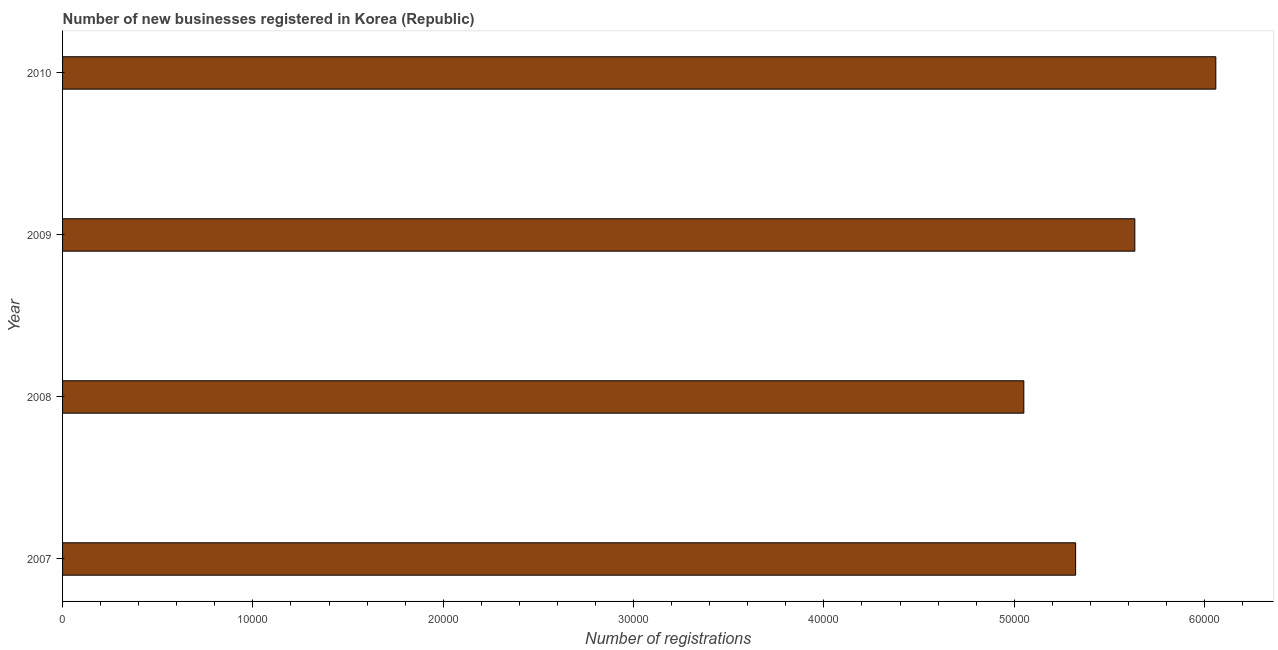Does the graph contain grids?
Provide a succinct answer. No. What is the title of the graph?
Your answer should be very brief. Number of new businesses registered in Korea (Republic). What is the label or title of the X-axis?
Your response must be concise. Number of registrations. What is the number of new business registrations in 2008?
Keep it short and to the point. 5.05e+04. Across all years, what is the maximum number of new business registrations?
Offer a terse response. 6.06e+04. Across all years, what is the minimum number of new business registrations?
Give a very brief answer. 5.05e+04. What is the sum of the number of new business registrations?
Provide a succinct answer. 2.21e+05. What is the difference between the number of new business registrations in 2009 and 2010?
Keep it short and to the point. -4256. What is the average number of new business registrations per year?
Provide a succinct answer. 5.52e+04. What is the median number of new business registrations?
Your response must be concise. 5.48e+04. Do a majority of the years between 2008 and 2010 (inclusive) have number of new business registrations greater than 8000 ?
Give a very brief answer. Yes. What is the ratio of the number of new business registrations in 2007 to that in 2008?
Offer a terse response. 1.05. Is the number of new business registrations in 2007 less than that in 2009?
Your answer should be compact. Yes. What is the difference between the highest and the second highest number of new business registrations?
Ensure brevity in your answer.  4256. Is the sum of the number of new business registrations in 2007 and 2009 greater than the maximum number of new business registrations across all years?
Offer a terse response. Yes. What is the difference between the highest and the lowest number of new business registrations?
Provide a succinct answer. 1.01e+04. In how many years, is the number of new business registrations greater than the average number of new business registrations taken over all years?
Offer a terse response. 2. Are all the bars in the graph horizontal?
Offer a terse response. Yes. How many years are there in the graph?
Offer a terse response. 4. What is the difference between two consecutive major ticks on the X-axis?
Provide a short and direct response. 10000. Are the values on the major ticks of X-axis written in scientific E-notation?
Your response must be concise. No. What is the Number of registrations in 2007?
Your answer should be compact. 5.32e+04. What is the Number of registrations in 2008?
Give a very brief answer. 5.05e+04. What is the Number of registrations in 2009?
Offer a very short reply. 5.63e+04. What is the Number of registrations in 2010?
Provide a succinct answer. 6.06e+04. What is the difference between the Number of registrations in 2007 and 2008?
Your response must be concise. 2722. What is the difference between the Number of registrations in 2007 and 2009?
Offer a terse response. -3110. What is the difference between the Number of registrations in 2007 and 2010?
Provide a short and direct response. -7366. What is the difference between the Number of registrations in 2008 and 2009?
Provide a succinct answer. -5832. What is the difference between the Number of registrations in 2008 and 2010?
Give a very brief answer. -1.01e+04. What is the difference between the Number of registrations in 2009 and 2010?
Provide a succinct answer. -4256. What is the ratio of the Number of registrations in 2007 to that in 2008?
Offer a very short reply. 1.05. What is the ratio of the Number of registrations in 2007 to that in 2009?
Offer a terse response. 0.94. What is the ratio of the Number of registrations in 2007 to that in 2010?
Your response must be concise. 0.88. What is the ratio of the Number of registrations in 2008 to that in 2009?
Your answer should be very brief. 0.9. What is the ratio of the Number of registrations in 2008 to that in 2010?
Provide a short and direct response. 0.83. 